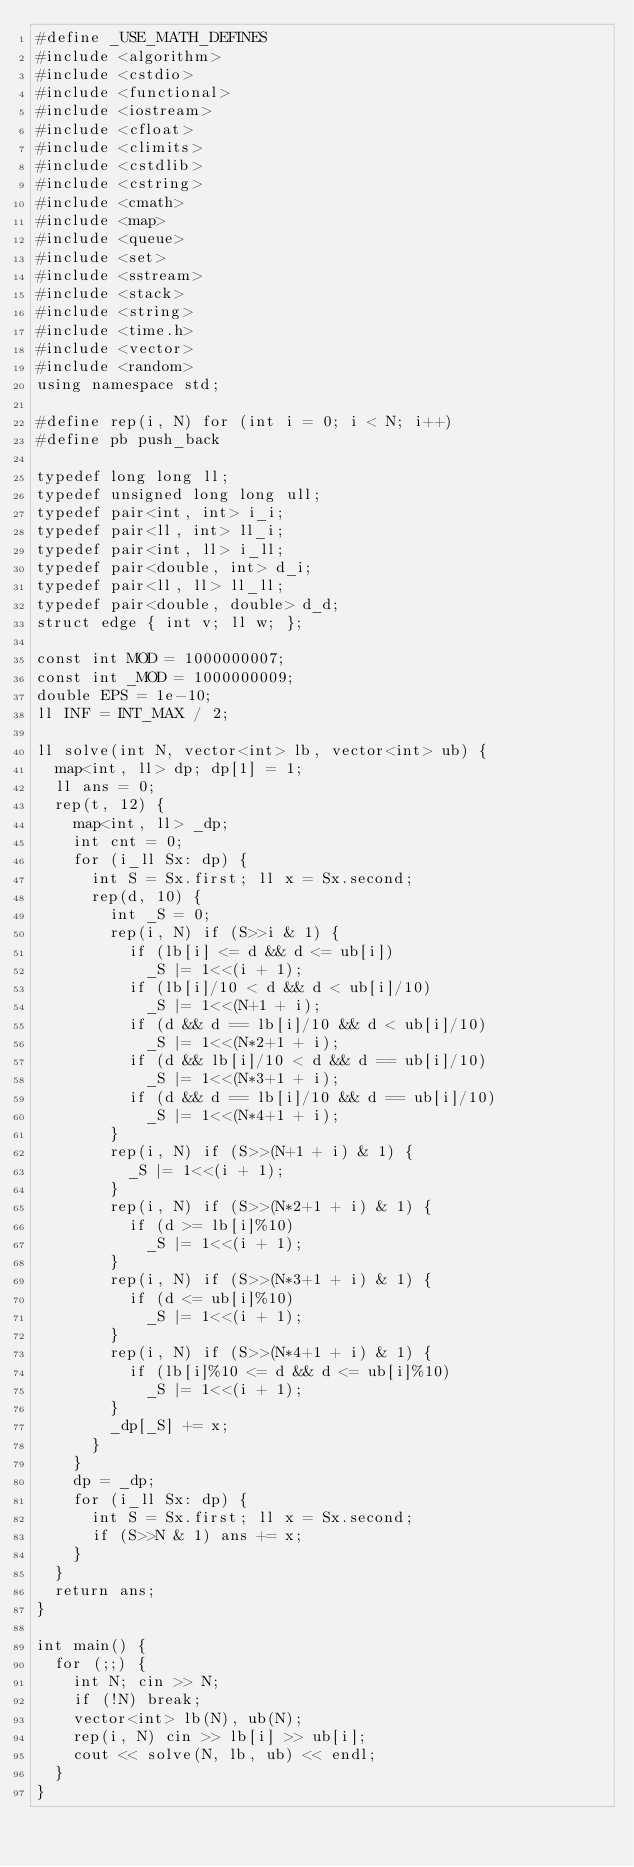Convert code to text. <code><loc_0><loc_0><loc_500><loc_500><_C++_>#define _USE_MATH_DEFINES
#include <algorithm>
#include <cstdio>
#include <functional>
#include <iostream>
#include <cfloat>
#include <climits>
#include <cstdlib>
#include <cstring>
#include <cmath>
#include <map>
#include <queue>
#include <set>
#include <sstream>
#include <stack>
#include <string>
#include <time.h>
#include <vector>
#include <random>
using namespace std;

#define rep(i, N) for (int i = 0; i < N; i++)
#define pb push_back

typedef long long ll;
typedef unsigned long long ull;
typedef pair<int, int> i_i;
typedef pair<ll, int> ll_i;
typedef pair<int, ll> i_ll;
typedef pair<double, int> d_i;
typedef pair<ll, ll> ll_ll;
typedef pair<double, double> d_d;
struct edge { int v; ll w; };

const int MOD = 1000000007;
const int _MOD = 1000000009;
double EPS = 1e-10;
ll INF = INT_MAX / 2;

ll solve(int N, vector<int> lb, vector<int> ub) {
	map<int, ll> dp; dp[1] = 1;
	ll ans = 0;
	rep(t, 12) {
		map<int, ll> _dp;
		int cnt = 0;
		for (i_ll Sx: dp) {
			int S = Sx.first; ll x = Sx.second;
			rep(d, 10) {
				int _S = 0;
				rep(i, N) if (S>>i & 1) {
					if (lb[i] <= d && d <= ub[i])
						_S |= 1<<(i + 1);
					if (lb[i]/10 < d && d < ub[i]/10)
						_S |= 1<<(N+1 + i);
					if (d && d == lb[i]/10 && d < ub[i]/10)
						_S |= 1<<(N*2+1 + i);
					if (d && lb[i]/10 < d && d == ub[i]/10)
						_S |= 1<<(N*3+1 + i);
					if (d && d == lb[i]/10 && d == ub[i]/10)
						_S |= 1<<(N*4+1 + i);
				}
				rep(i, N) if (S>>(N+1 + i) & 1) {
					_S |= 1<<(i + 1);
				}
				rep(i, N) if (S>>(N*2+1 + i) & 1) {
					if (d >= lb[i]%10)
						_S |= 1<<(i + 1);
				}
				rep(i, N) if (S>>(N*3+1 + i) & 1) {
					if (d <= ub[i]%10)
						_S |= 1<<(i + 1);
				}
				rep(i, N) if (S>>(N*4+1 + i) & 1) {
					if (lb[i]%10 <= d && d <= ub[i]%10)
						_S |= 1<<(i + 1);
				}
				_dp[_S] += x;
			}
		}
		dp = _dp;
		for (i_ll Sx: dp) {
			int S = Sx.first; ll x = Sx.second;
			if (S>>N & 1) ans += x;
		}
	}
	return ans;
}

int main() {
	for (;;) {
		int N; cin >> N;
		if (!N) break;
		vector<int> lb(N), ub(N);
		rep(i, N) cin >> lb[i] >> ub[i];
		cout << solve(N, lb, ub) << endl;
	}
}</code> 